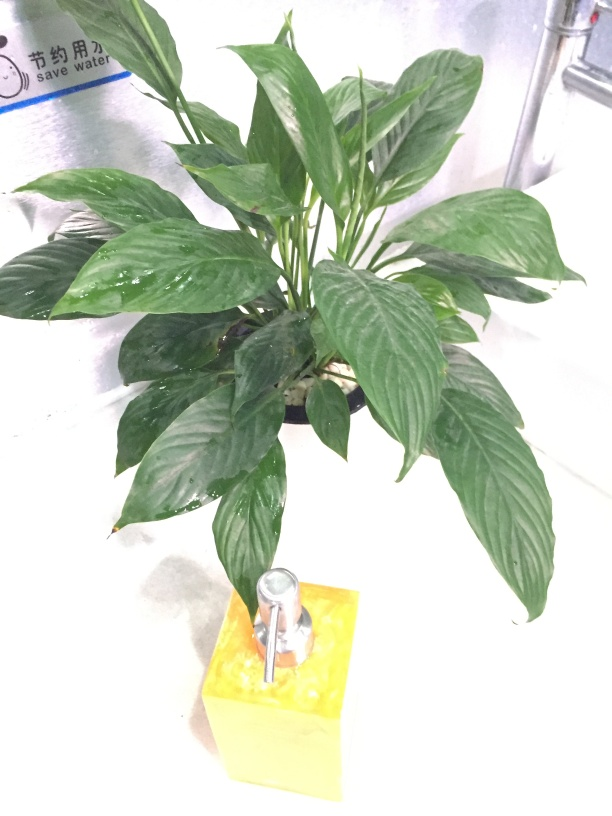Is this plant commonly found indoors, and if so, what benefits does it provide? Yes, the plant in the image is commonly kept indoors. It is known for its air-purifying qualities, as it can help remove toxins from the environment. Such plants also contribute to the aesthetic of a space and can have a calming effect on individuals in the area. 